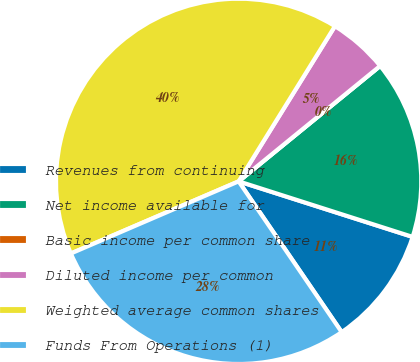Convert chart to OTSL. <chart><loc_0><loc_0><loc_500><loc_500><pie_chart><fcel>Revenues from continuing<fcel>Net income available for<fcel>Basic income per common share<fcel>Diluted income per common<fcel>Weighted average common shares<fcel>Funds From Operations (1)<nl><fcel>10.54%<fcel>15.81%<fcel>0.0%<fcel>5.27%<fcel>40.3%<fcel>28.08%<nl></chart> 